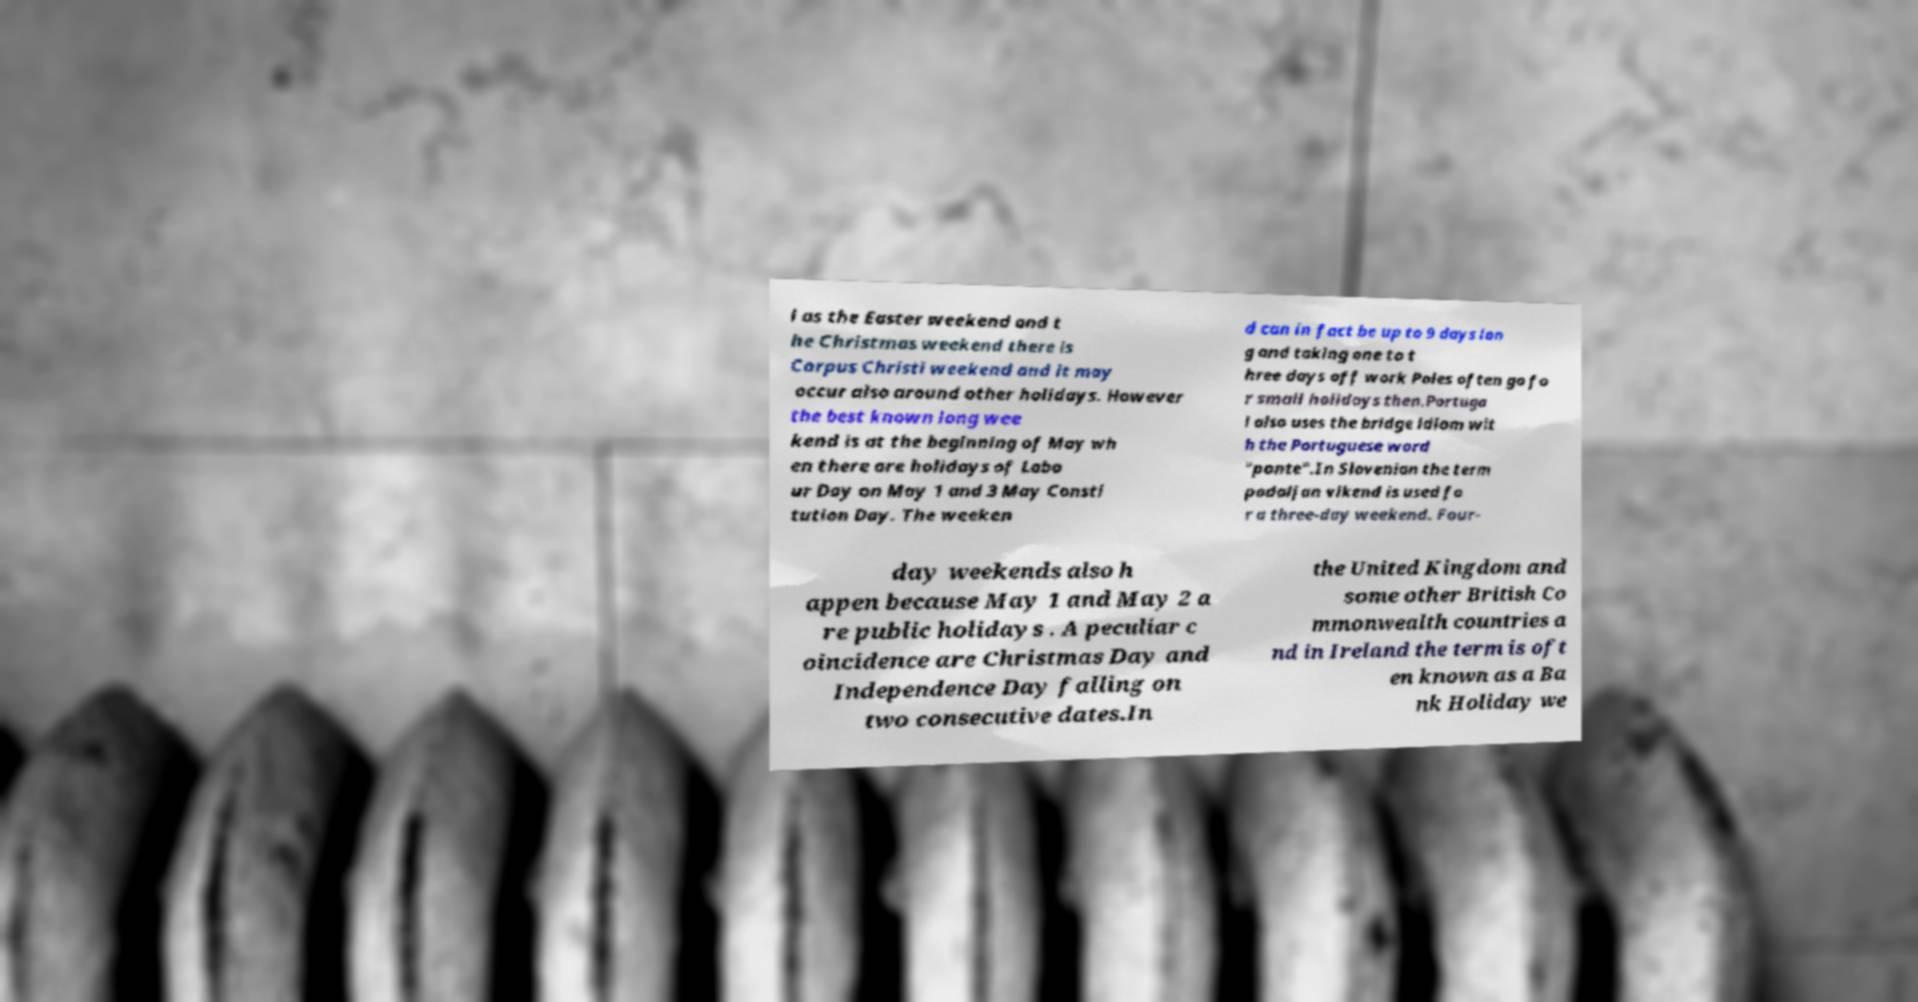What messages or text are displayed in this image? I need them in a readable, typed format. l as the Easter weekend and t he Christmas weekend there is Corpus Christi weekend and it may occur also around other holidays. However the best known long wee kend is at the beginning of May wh en there are holidays of Labo ur Day on May 1 and 3 May Consti tution Day. The weeken d can in fact be up to 9 days lon g and taking one to t hree days off work Poles often go fo r small holidays then.Portuga l also uses the bridge idiom wit h the Portuguese word "ponte".In Slovenian the term podaljan vikend is used fo r a three-day weekend. Four- day weekends also h appen because May 1 and May 2 a re public holidays . A peculiar c oincidence are Christmas Day and Independence Day falling on two consecutive dates.In the United Kingdom and some other British Co mmonwealth countries a nd in Ireland the term is oft en known as a Ba nk Holiday we 